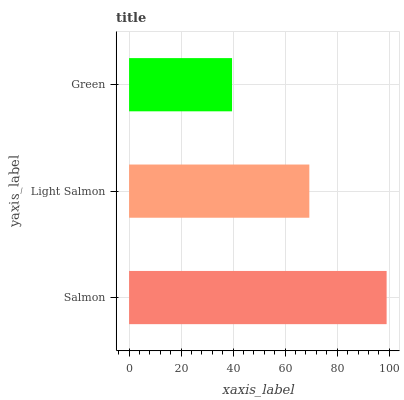Is Green the minimum?
Answer yes or no. Yes. Is Salmon the maximum?
Answer yes or no. Yes. Is Light Salmon the minimum?
Answer yes or no. No. Is Light Salmon the maximum?
Answer yes or no. No. Is Salmon greater than Light Salmon?
Answer yes or no. Yes. Is Light Salmon less than Salmon?
Answer yes or no. Yes. Is Light Salmon greater than Salmon?
Answer yes or no. No. Is Salmon less than Light Salmon?
Answer yes or no. No. Is Light Salmon the high median?
Answer yes or no. Yes. Is Light Salmon the low median?
Answer yes or no. Yes. Is Green the high median?
Answer yes or no. No. Is Salmon the low median?
Answer yes or no. No. 